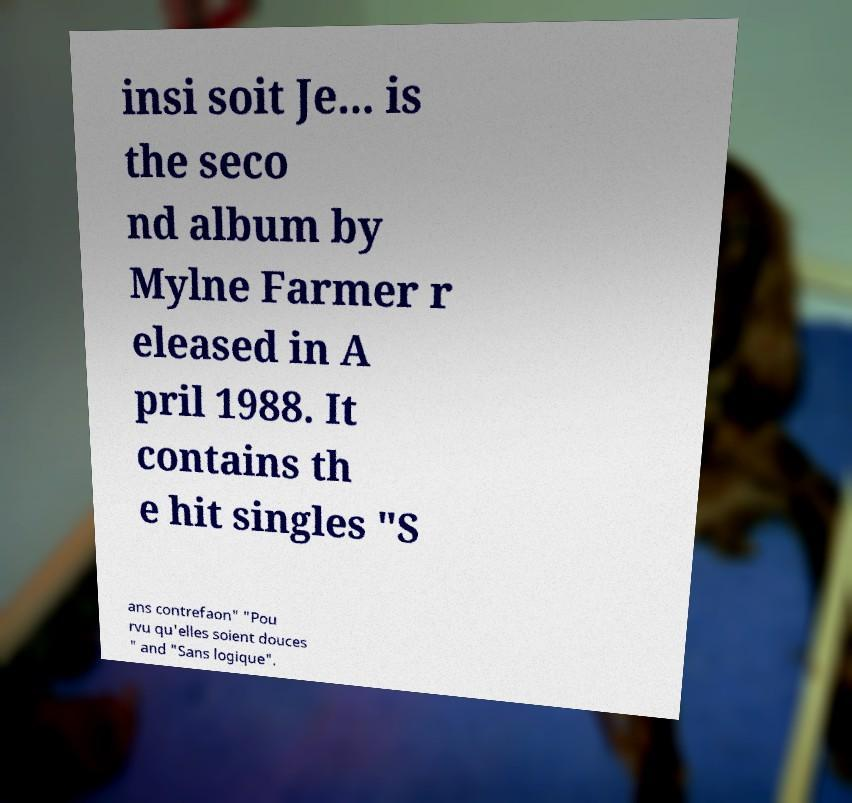Could you assist in decoding the text presented in this image and type it out clearly? insi soit Je... is the seco nd album by Mylne Farmer r eleased in A pril 1988. It contains th e hit singles "S ans contrefaon" "Pou rvu qu'elles soient douces " and "Sans logique". 